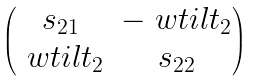Convert formula to latex. <formula><loc_0><loc_0><loc_500><loc_500>\begin{pmatrix} s _ { 2 1 } & - \ w t i l { t _ { 2 } } \\ \ w t i l { t _ { 2 } } & s _ { 2 2 } \end{pmatrix}</formula> 